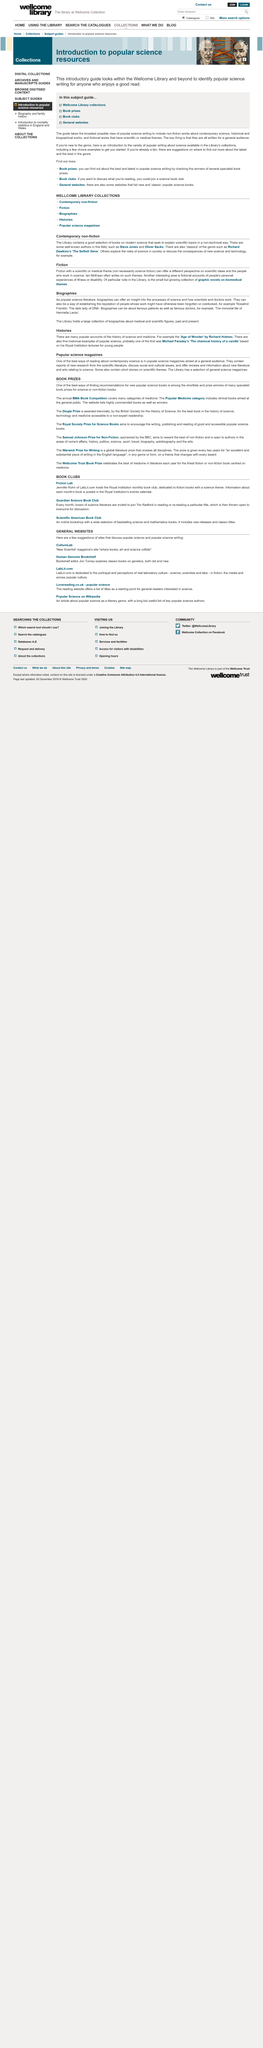Specify some key components in this picture. Reviewing book prize shortlists and winners is an excellent way to discover new and popular science books. The Library possesses books that provide explanations of scientific topics in a manner that is not technical in nature. The target audience for popular science magazines is the general public. Fiction with scientific or medical themes provides a fresh viewpoint on scientific concepts and the individuals who pursue these fields. The BMA Book Competition takes place annually. 